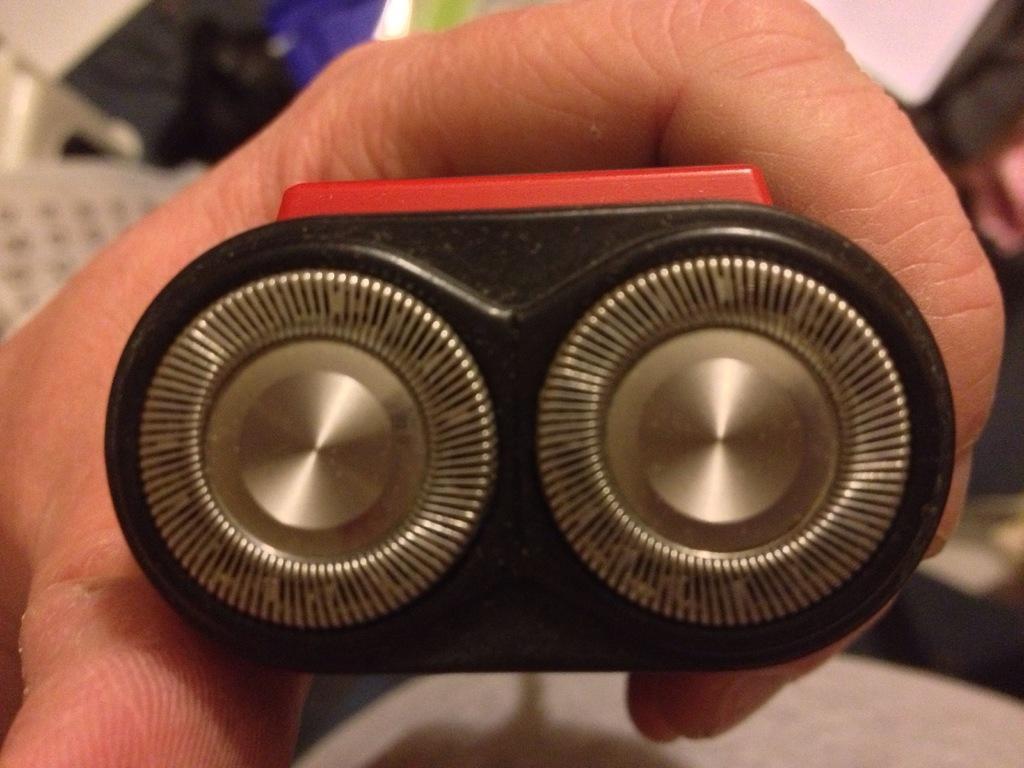How would you summarize this image in a sentence or two? Here we can see hand of a person holding an object. 